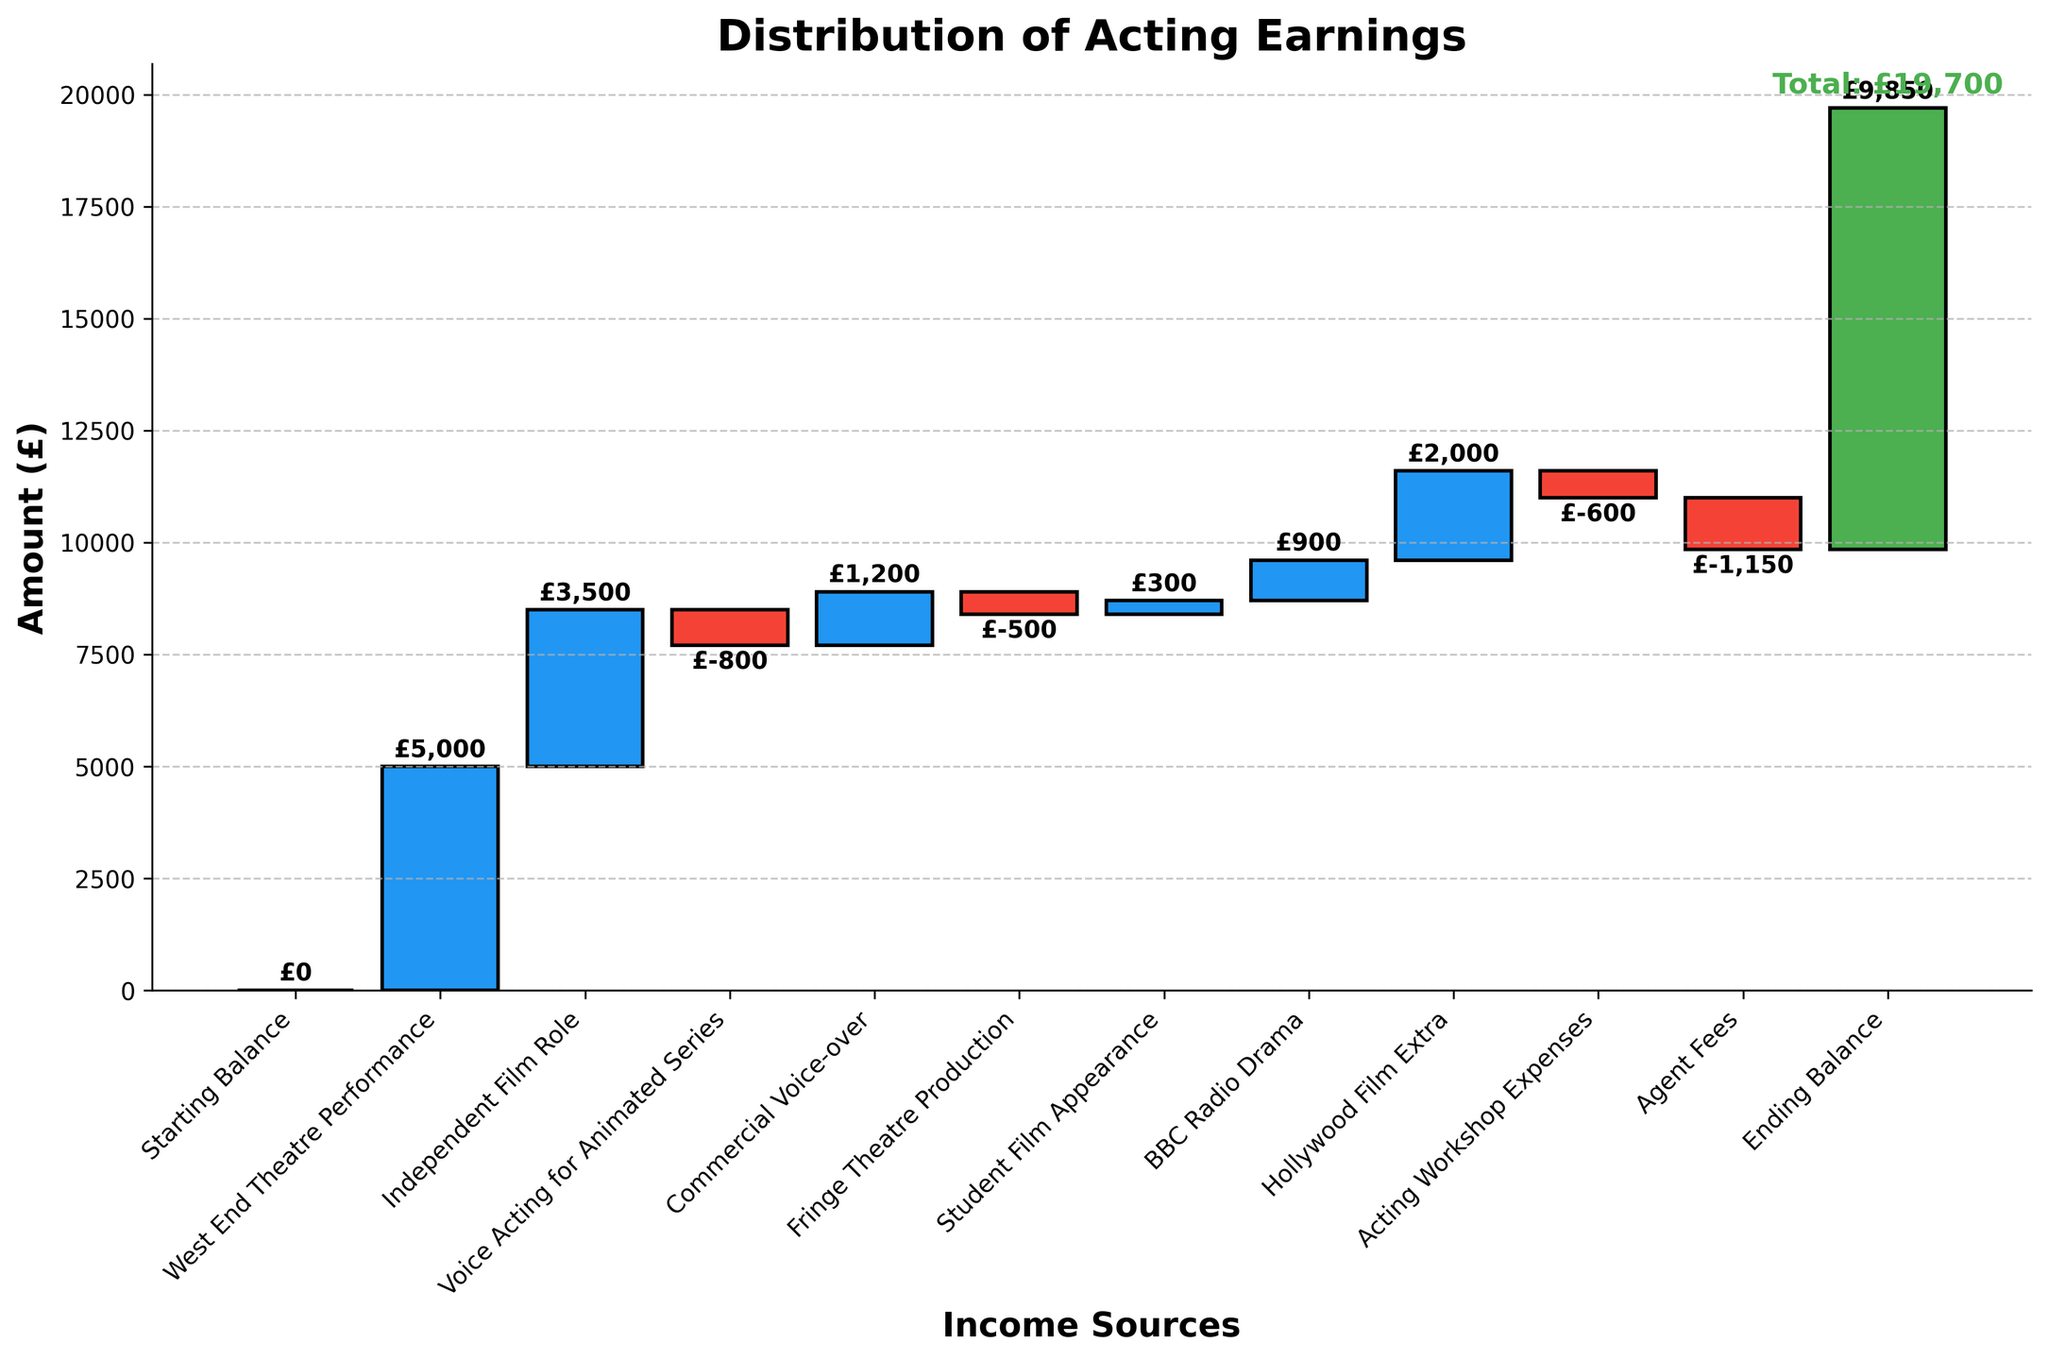What is the title of the chart? The title is always at the top of the chart and is meant to provide a brief description of what the chart is about.
Answer: Distribution of Acting Earnings What is the total earnings at the end? The last bar in the chart represents the Ending Balance. The green color indicates the final cumulative amount after all other earnings and expenses. From the label, the ending balance is £9850.
Answer: £9850 Which earning source contributed the most to the total earnings? By looking at the height of the positive bars, we can see which one is the tallest. The West End Theatre Performance bar is the tallest positive bar, indicating it contributed the most.
Answer: West End Theatre Performance How much did the Commercial Voice-over add to the balance? The Commercial Voice-over is an individual category listed on the x-axis. By looking at its height and the label, we can see it added £1200 to the balance.
Answer: £1200 Which expense had the largest negative impact? Red bars indicate negative amounts. By comparing the heights of the red bars, Agent Fees are shown as the most significant expense.
Answer: Agent Fees What is the cumulative amount just before the Ending Balance? The cumulative amount before the Ending Balance would be the sum of all bars except the final one. From the chart, this amount is £9850 minus the Ending Balance amount, which is the same since Ending Balance is the final amount itself.
Answer: £9850 How many positive contributions are there, and how many negative? Positive contributions are the blue bars, and negative contributions are the red bars. By counting, there are 6 positive contributions and 3 negative contributions.
Answer: 6 positive, 3 negative What is the cumulative balance after the Fringe Theatre Production? Cumulative balance after each category is the sum of all categories up to that point. Starting from 0, and adding the amounts sequentially, after Fringe Theatre Production (£5000 + £3500 - £800 + £1200 - £500), the balance is £9400.
Answer: £9400 What is the difference between the earnings from the Independent Film Role and the Hollywood Film Extra? To find the difference, subtract the amount of one from the other. The Independent Film Role earned £3500, and the Hollywood Film Extra earned £2000. So, £3500 - £2000.
Answer: £1500 If the Acting Workshop Expenses were £400 instead of £600, what would be the new Ending Balance? By reducing the Acting Workshop Expenses by £200, the Ending Balance would increase by £200. The current Ending Balance is £9850, so £9850 + £200.
Answer: £10050 